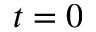Convert formula to latex. <formula><loc_0><loc_0><loc_500><loc_500>t = 0</formula> 